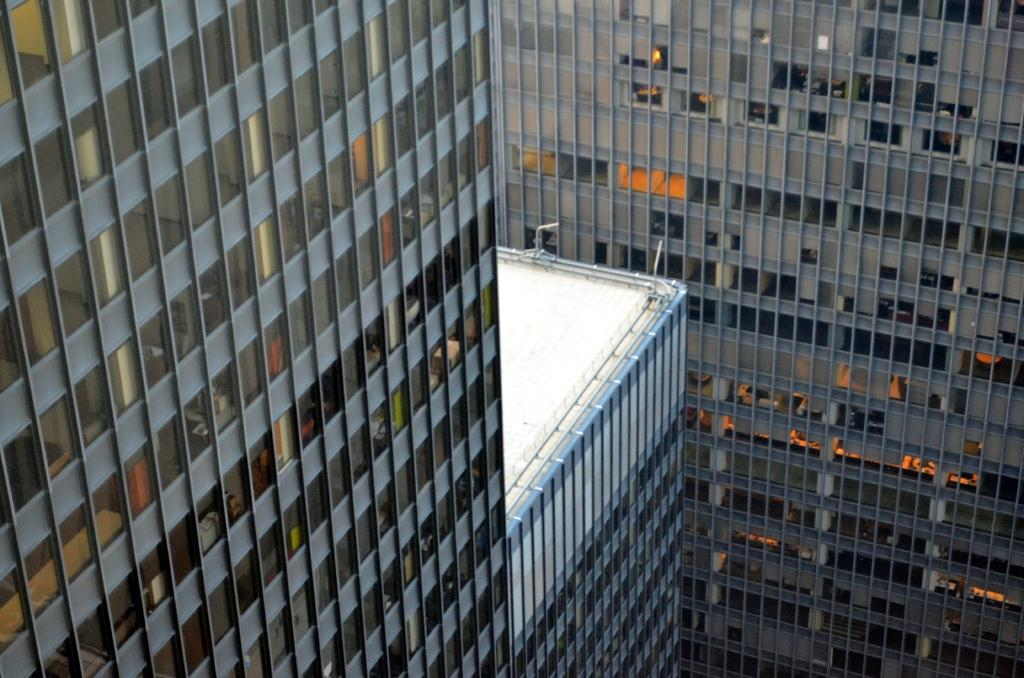What structures are visible in the image? There are buildings in the image. What feature can be seen on the buildings? The buildings have windows. What advice does your aunt give in the image? There is no mention of an aunt or any advice in the image; it only features buildings with windows. 